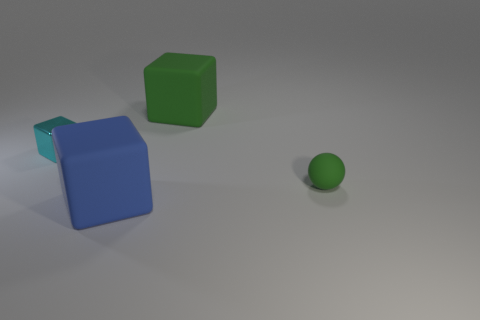Add 1 small cubes. How many objects exist? 5 Subtract all cubes. How many objects are left? 1 Add 4 big purple rubber objects. How many big purple rubber objects exist? 4 Subtract 0 purple balls. How many objects are left? 4 Subtract all blue cubes. Subtract all big blue cubes. How many objects are left? 2 Add 1 tiny metal cubes. How many tiny metal cubes are left? 2 